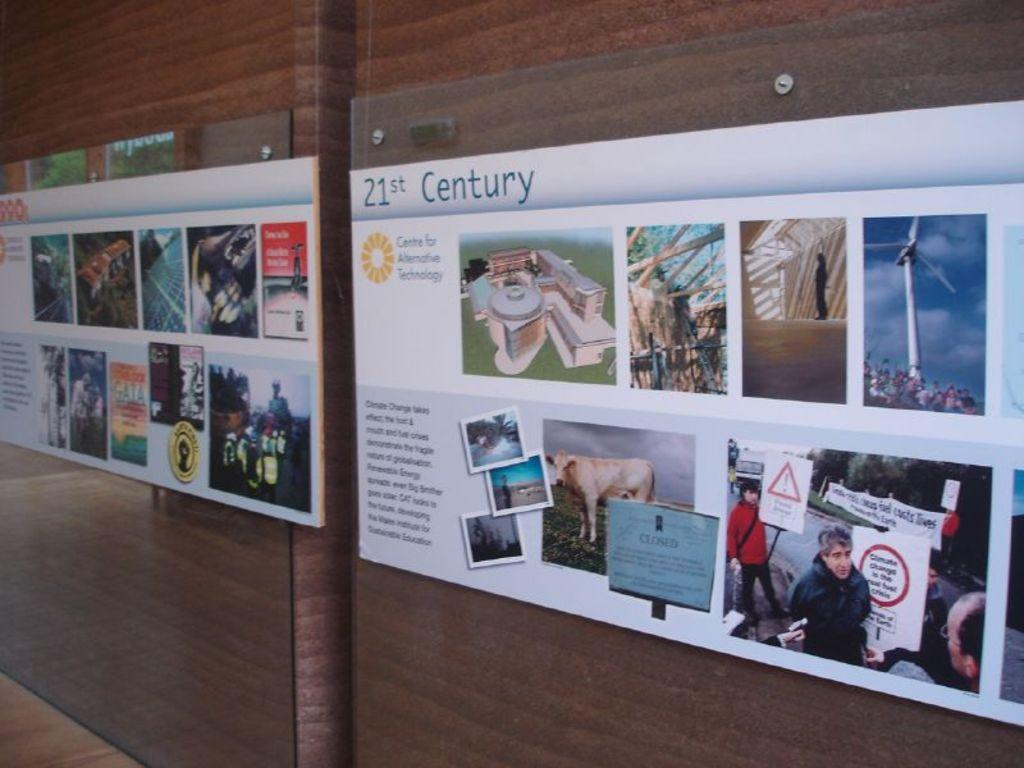<image>
Share a concise interpretation of the image provided. Two posters are displayed side by side on a wall that contain images and text regarding alternative technology 